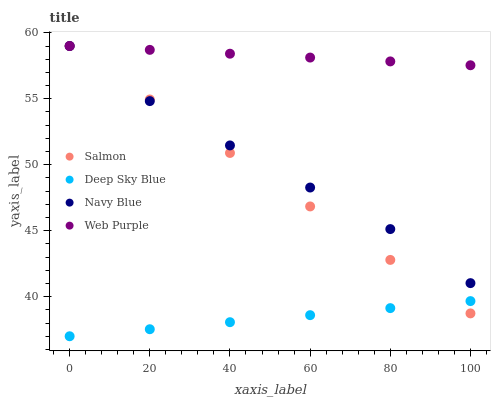Does Deep Sky Blue have the minimum area under the curve?
Answer yes or no. Yes. Does Web Purple have the maximum area under the curve?
Answer yes or no. Yes. Does Salmon have the minimum area under the curve?
Answer yes or no. No. Does Salmon have the maximum area under the curve?
Answer yes or no. No. Is Web Purple the smoothest?
Answer yes or no. Yes. Is Navy Blue the roughest?
Answer yes or no. Yes. Is Salmon the smoothest?
Answer yes or no. No. Is Salmon the roughest?
Answer yes or no. No. Does Deep Sky Blue have the lowest value?
Answer yes or no. Yes. Does Salmon have the lowest value?
Answer yes or no. No. Does Salmon have the highest value?
Answer yes or no. Yes. Does Deep Sky Blue have the highest value?
Answer yes or no. No. Is Deep Sky Blue less than Web Purple?
Answer yes or no. Yes. Is Web Purple greater than Deep Sky Blue?
Answer yes or no. Yes. Does Web Purple intersect Salmon?
Answer yes or no. Yes. Is Web Purple less than Salmon?
Answer yes or no. No. Is Web Purple greater than Salmon?
Answer yes or no. No. Does Deep Sky Blue intersect Web Purple?
Answer yes or no. No. 